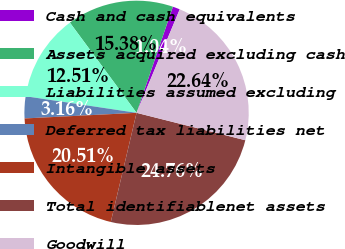<chart> <loc_0><loc_0><loc_500><loc_500><pie_chart><fcel>Cash and cash equivalents<fcel>Assets acquired excluding cash<fcel>Liabilities assumed excluding<fcel>Deferred tax liabilities net<fcel>Intangible assets<fcel>Total identifiablenet assets<fcel>Goodwill<nl><fcel>1.04%<fcel>15.38%<fcel>12.51%<fcel>3.16%<fcel>20.51%<fcel>24.76%<fcel>22.64%<nl></chart> 